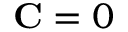Convert formula to latex. <formula><loc_0><loc_0><loc_500><loc_500>C = 0</formula> 